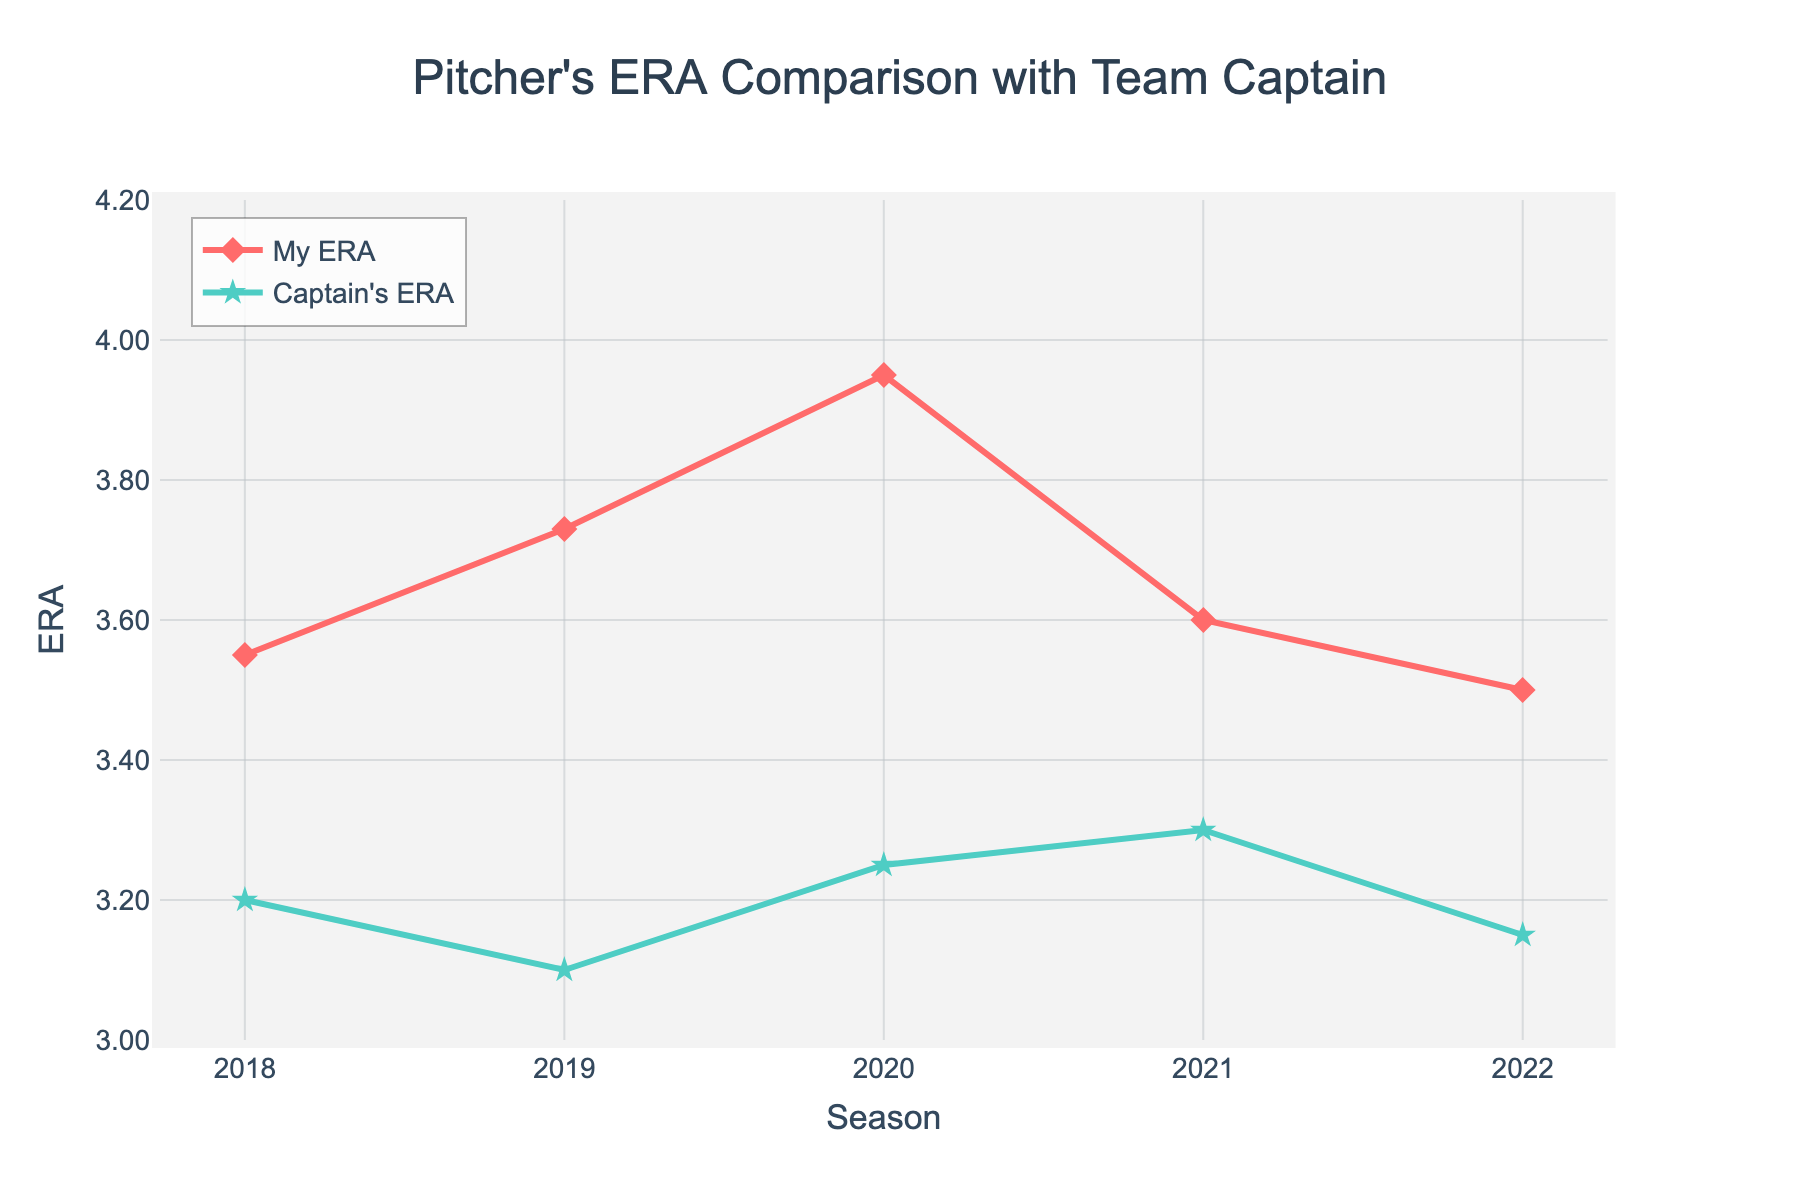How many seasons are displayed in the figure? Count the number of data points on the x-axis labeled "Season." There are tick marks corresponding to each year from 2018 to 2022, making a total of five seasons.
Answer: Five What's the overall trend in my ERA from 2018 to 2022? Observe the line representing "My ERA" over the seasons. It increases from 2018 to 2020, slightly decreases in 2021, and then continues to decrease in 2022. Thus, the trend appears initially upward, followed by a downward trend.
Answer: Initially upward, then downward In which season was the difference between my ERA and the captain's ERA the largest? Calculate the difference between "My ERA" and "Captain's ERA" for each season: 2018 (0.35), 2019 (0.63), 2020 (0.70), 2021 (0.30), 2022 (0.35). The largest difference is 0.70 in 2020.
Answer: 2020 What is the average ERA for both me and the captain over the reported seasons? Calculate the average of "My ERA" and "Captain's ERA." For me: (3.55 + 3.73 + 3.95 + 3.60 + 3.50) / 5 = 3.67. For the captain: (3.20 + 3.10 + 3.25 + 3.30 + 3.15) / 5 = 3.20.
Answer: My ERA: 3.67, Captain's ERA: 3.20 Which season had the lowest ERA for both me and the captain? Identify the lowest data point in "My ERA" and "Captain's ERA." For me, the lowest ERA is 3.50 in 2022. For the captain, the lowest ERA is 3.10 in 2019.
Answer: My ERA: 2022, Captain's ERA: 2019 How does my ERA compare to the captain's ERA in each season? For each season, compare "My ERA" with "Captain's ERA": 
2018: 3.55 vs 3.20 
2019: 3.73 vs 3.10 
2020: 3.95 vs 3.25 
2021: 3.60 vs 3.30 
2022: 3.50 vs 3.15. My ERA is always higher in each season.
Answer: My ERA is always higher What is the average difference in ERA between me and the captain across all seasons? Calculate the difference for each season and then average them: (0.35 + 0.63 + 0.70 + 0.30 + 0.35) / 5 ≈ 0.47.
Answer: 0.47 If the trend continues, what would be a reasonable estimate of my ERA for the next season? Observe the downward trend in "My ERA" from 2020 to 2022, decreasing from 3.95 to 3.50 over three seasons. Assuming a consistent decrease, calculate the average reduction per season: (3.95 - 3.50) / 2 = 0.225. Estimate my ERA for 2023 as 3.50 - 0.225 ≈ 3.28.
Answer: Approximately 3.28 